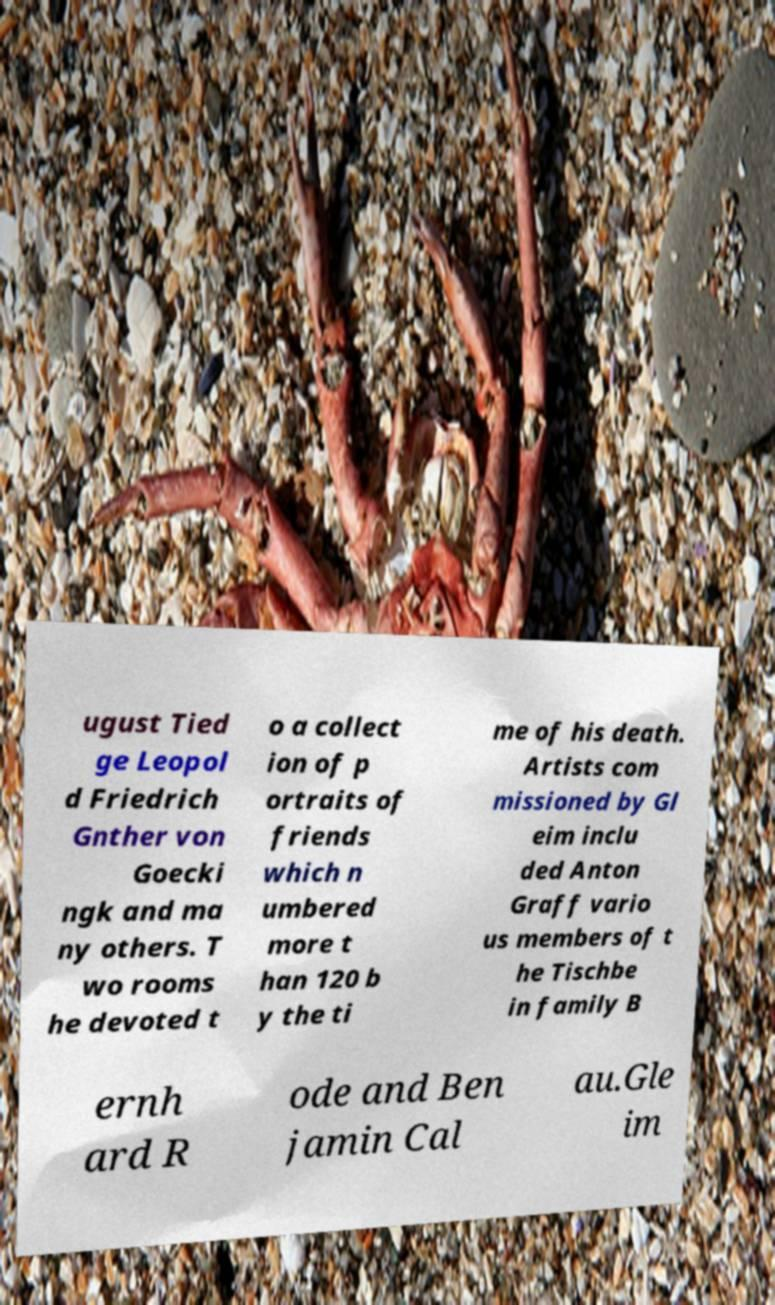Can you read and provide the text displayed in the image?This photo seems to have some interesting text. Can you extract and type it out for me? ugust Tied ge Leopol d Friedrich Gnther von Goecki ngk and ma ny others. T wo rooms he devoted t o a collect ion of p ortraits of friends which n umbered more t han 120 b y the ti me of his death. Artists com missioned by Gl eim inclu ded Anton Graff vario us members of t he Tischbe in family B ernh ard R ode and Ben jamin Cal au.Gle im 